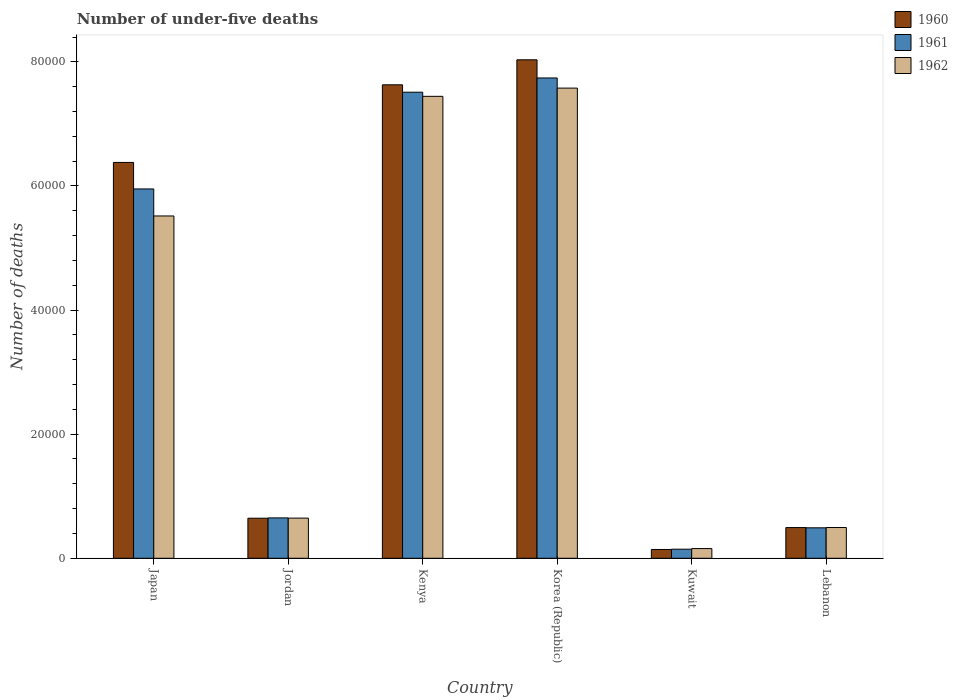How many groups of bars are there?
Provide a succinct answer. 6. Are the number of bars per tick equal to the number of legend labels?
Your answer should be compact. Yes. How many bars are there on the 3rd tick from the left?
Provide a succinct answer. 3. What is the number of under-five deaths in 1960 in Lebanon?
Ensure brevity in your answer.  4947. Across all countries, what is the maximum number of under-five deaths in 1962?
Offer a very short reply. 7.58e+04. Across all countries, what is the minimum number of under-five deaths in 1962?
Provide a short and direct response. 1563. In which country was the number of under-five deaths in 1962 minimum?
Give a very brief answer. Kuwait. What is the total number of under-five deaths in 1961 in the graph?
Keep it short and to the point. 2.25e+05. What is the difference between the number of under-five deaths in 1961 in Japan and that in Kuwait?
Provide a short and direct response. 5.81e+04. What is the difference between the number of under-five deaths in 1962 in Kenya and the number of under-five deaths in 1961 in Lebanon?
Your answer should be very brief. 6.95e+04. What is the average number of under-five deaths in 1961 per country?
Your response must be concise. 3.75e+04. What is the difference between the number of under-five deaths of/in 1962 and number of under-five deaths of/in 1960 in Kenya?
Keep it short and to the point. -1857. What is the ratio of the number of under-five deaths in 1961 in Japan to that in Lebanon?
Offer a very short reply. 12.13. Is the difference between the number of under-five deaths in 1962 in Japan and Lebanon greater than the difference between the number of under-five deaths in 1960 in Japan and Lebanon?
Provide a short and direct response. No. What is the difference between the highest and the second highest number of under-five deaths in 1962?
Offer a terse response. 1327. What is the difference between the highest and the lowest number of under-five deaths in 1962?
Ensure brevity in your answer.  7.42e+04. Is the sum of the number of under-five deaths in 1961 in Jordan and Kenya greater than the maximum number of under-five deaths in 1960 across all countries?
Provide a short and direct response. Yes. What does the 3rd bar from the right in Kenya represents?
Your answer should be very brief. 1960. Are all the bars in the graph horizontal?
Your response must be concise. No. What is the difference between two consecutive major ticks on the Y-axis?
Your answer should be compact. 2.00e+04. Does the graph contain grids?
Provide a succinct answer. No. How many legend labels are there?
Provide a succinct answer. 3. What is the title of the graph?
Provide a short and direct response. Number of under-five deaths. What is the label or title of the Y-axis?
Ensure brevity in your answer.  Number of deaths. What is the Number of deaths in 1960 in Japan?
Offer a terse response. 6.38e+04. What is the Number of deaths of 1961 in Japan?
Offer a terse response. 5.95e+04. What is the Number of deaths of 1962 in Japan?
Give a very brief answer. 5.52e+04. What is the Number of deaths in 1960 in Jordan?
Give a very brief answer. 6455. What is the Number of deaths in 1961 in Jordan?
Your answer should be compact. 6506. What is the Number of deaths in 1962 in Jordan?
Provide a short and direct response. 6471. What is the Number of deaths of 1960 in Kenya?
Your answer should be very brief. 7.63e+04. What is the Number of deaths of 1961 in Kenya?
Keep it short and to the point. 7.51e+04. What is the Number of deaths in 1962 in Kenya?
Ensure brevity in your answer.  7.44e+04. What is the Number of deaths in 1960 in Korea (Republic)?
Your answer should be compact. 8.03e+04. What is the Number of deaths of 1961 in Korea (Republic)?
Your answer should be compact. 7.74e+04. What is the Number of deaths of 1962 in Korea (Republic)?
Keep it short and to the point. 7.58e+04. What is the Number of deaths in 1960 in Kuwait?
Your response must be concise. 1416. What is the Number of deaths in 1961 in Kuwait?
Offer a terse response. 1463. What is the Number of deaths in 1962 in Kuwait?
Give a very brief answer. 1563. What is the Number of deaths of 1960 in Lebanon?
Make the answer very short. 4947. What is the Number of deaths in 1961 in Lebanon?
Your answer should be compact. 4907. What is the Number of deaths in 1962 in Lebanon?
Make the answer very short. 4956. Across all countries, what is the maximum Number of deaths of 1960?
Provide a succinct answer. 8.03e+04. Across all countries, what is the maximum Number of deaths in 1961?
Give a very brief answer. 7.74e+04. Across all countries, what is the maximum Number of deaths of 1962?
Offer a terse response. 7.58e+04. Across all countries, what is the minimum Number of deaths in 1960?
Offer a very short reply. 1416. Across all countries, what is the minimum Number of deaths of 1961?
Your answer should be very brief. 1463. Across all countries, what is the minimum Number of deaths of 1962?
Provide a succinct answer. 1563. What is the total Number of deaths in 1960 in the graph?
Your response must be concise. 2.33e+05. What is the total Number of deaths of 1961 in the graph?
Provide a succinct answer. 2.25e+05. What is the total Number of deaths in 1962 in the graph?
Your answer should be very brief. 2.18e+05. What is the difference between the Number of deaths of 1960 in Japan and that in Jordan?
Make the answer very short. 5.73e+04. What is the difference between the Number of deaths in 1961 in Japan and that in Jordan?
Offer a very short reply. 5.30e+04. What is the difference between the Number of deaths in 1962 in Japan and that in Jordan?
Provide a short and direct response. 4.87e+04. What is the difference between the Number of deaths in 1960 in Japan and that in Kenya?
Your answer should be compact. -1.25e+04. What is the difference between the Number of deaths of 1961 in Japan and that in Kenya?
Your answer should be compact. -1.56e+04. What is the difference between the Number of deaths in 1962 in Japan and that in Kenya?
Provide a short and direct response. -1.93e+04. What is the difference between the Number of deaths in 1960 in Japan and that in Korea (Republic)?
Keep it short and to the point. -1.65e+04. What is the difference between the Number of deaths of 1961 in Japan and that in Korea (Republic)?
Keep it short and to the point. -1.79e+04. What is the difference between the Number of deaths in 1962 in Japan and that in Korea (Republic)?
Ensure brevity in your answer.  -2.06e+04. What is the difference between the Number of deaths in 1960 in Japan and that in Kuwait?
Your answer should be compact. 6.24e+04. What is the difference between the Number of deaths of 1961 in Japan and that in Kuwait?
Offer a terse response. 5.81e+04. What is the difference between the Number of deaths in 1962 in Japan and that in Kuwait?
Ensure brevity in your answer.  5.36e+04. What is the difference between the Number of deaths of 1960 in Japan and that in Lebanon?
Make the answer very short. 5.88e+04. What is the difference between the Number of deaths of 1961 in Japan and that in Lebanon?
Give a very brief answer. 5.46e+04. What is the difference between the Number of deaths of 1962 in Japan and that in Lebanon?
Your response must be concise. 5.02e+04. What is the difference between the Number of deaths of 1960 in Jordan and that in Kenya?
Provide a succinct answer. -6.98e+04. What is the difference between the Number of deaths in 1961 in Jordan and that in Kenya?
Your answer should be compact. -6.86e+04. What is the difference between the Number of deaths in 1962 in Jordan and that in Kenya?
Your response must be concise. -6.80e+04. What is the difference between the Number of deaths in 1960 in Jordan and that in Korea (Republic)?
Your answer should be very brief. -7.39e+04. What is the difference between the Number of deaths in 1961 in Jordan and that in Korea (Republic)?
Keep it short and to the point. -7.09e+04. What is the difference between the Number of deaths in 1962 in Jordan and that in Korea (Republic)?
Keep it short and to the point. -6.93e+04. What is the difference between the Number of deaths of 1960 in Jordan and that in Kuwait?
Make the answer very short. 5039. What is the difference between the Number of deaths in 1961 in Jordan and that in Kuwait?
Your answer should be very brief. 5043. What is the difference between the Number of deaths in 1962 in Jordan and that in Kuwait?
Make the answer very short. 4908. What is the difference between the Number of deaths of 1960 in Jordan and that in Lebanon?
Offer a very short reply. 1508. What is the difference between the Number of deaths in 1961 in Jordan and that in Lebanon?
Keep it short and to the point. 1599. What is the difference between the Number of deaths of 1962 in Jordan and that in Lebanon?
Your response must be concise. 1515. What is the difference between the Number of deaths of 1960 in Kenya and that in Korea (Republic)?
Offer a very short reply. -4031. What is the difference between the Number of deaths of 1961 in Kenya and that in Korea (Republic)?
Offer a very short reply. -2297. What is the difference between the Number of deaths in 1962 in Kenya and that in Korea (Republic)?
Your response must be concise. -1327. What is the difference between the Number of deaths in 1960 in Kenya and that in Kuwait?
Offer a very short reply. 7.49e+04. What is the difference between the Number of deaths in 1961 in Kenya and that in Kuwait?
Ensure brevity in your answer.  7.36e+04. What is the difference between the Number of deaths of 1962 in Kenya and that in Kuwait?
Provide a succinct answer. 7.29e+04. What is the difference between the Number of deaths in 1960 in Kenya and that in Lebanon?
Make the answer very short. 7.14e+04. What is the difference between the Number of deaths in 1961 in Kenya and that in Lebanon?
Make the answer very short. 7.02e+04. What is the difference between the Number of deaths of 1962 in Kenya and that in Lebanon?
Offer a very short reply. 6.95e+04. What is the difference between the Number of deaths of 1960 in Korea (Republic) and that in Kuwait?
Make the answer very short. 7.89e+04. What is the difference between the Number of deaths of 1961 in Korea (Republic) and that in Kuwait?
Your answer should be very brief. 7.59e+04. What is the difference between the Number of deaths in 1962 in Korea (Republic) and that in Kuwait?
Provide a succinct answer. 7.42e+04. What is the difference between the Number of deaths in 1960 in Korea (Republic) and that in Lebanon?
Offer a terse response. 7.54e+04. What is the difference between the Number of deaths in 1961 in Korea (Republic) and that in Lebanon?
Keep it short and to the point. 7.25e+04. What is the difference between the Number of deaths of 1962 in Korea (Republic) and that in Lebanon?
Keep it short and to the point. 7.08e+04. What is the difference between the Number of deaths of 1960 in Kuwait and that in Lebanon?
Provide a succinct answer. -3531. What is the difference between the Number of deaths of 1961 in Kuwait and that in Lebanon?
Your answer should be compact. -3444. What is the difference between the Number of deaths of 1962 in Kuwait and that in Lebanon?
Ensure brevity in your answer.  -3393. What is the difference between the Number of deaths of 1960 in Japan and the Number of deaths of 1961 in Jordan?
Offer a terse response. 5.73e+04. What is the difference between the Number of deaths in 1960 in Japan and the Number of deaths in 1962 in Jordan?
Your answer should be very brief. 5.73e+04. What is the difference between the Number of deaths of 1961 in Japan and the Number of deaths of 1962 in Jordan?
Your answer should be compact. 5.30e+04. What is the difference between the Number of deaths in 1960 in Japan and the Number of deaths in 1961 in Kenya?
Keep it short and to the point. -1.13e+04. What is the difference between the Number of deaths of 1960 in Japan and the Number of deaths of 1962 in Kenya?
Provide a short and direct response. -1.07e+04. What is the difference between the Number of deaths in 1961 in Japan and the Number of deaths in 1962 in Kenya?
Make the answer very short. -1.49e+04. What is the difference between the Number of deaths in 1960 in Japan and the Number of deaths in 1961 in Korea (Republic)?
Provide a short and direct response. -1.36e+04. What is the difference between the Number of deaths of 1960 in Japan and the Number of deaths of 1962 in Korea (Republic)?
Offer a terse response. -1.20e+04. What is the difference between the Number of deaths in 1961 in Japan and the Number of deaths in 1962 in Korea (Republic)?
Offer a very short reply. -1.63e+04. What is the difference between the Number of deaths of 1960 in Japan and the Number of deaths of 1961 in Kuwait?
Offer a very short reply. 6.23e+04. What is the difference between the Number of deaths of 1960 in Japan and the Number of deaths of 1962 in Kuwait?
Provide a short and direct response. 6.22e+04. What is the difference between the Number of deaths of 1961 in Japan and the Number of deaths of 1962 in Kuwait?
Give a very brief answer. 5.80e+04. What is the difference between the Number of deaths of 1960 in Japan and the Number of deaths of 1961 in Lebanon?
Offer a very short reply. 5.89e+04. What is the difference between the Number of deaths in 1960 in Japan and the Number of deaths in 1962 in Lebanon?
Provide a short and direct response. 5.88e+04. What is the difference between the Number of deaths of 1961 in Japan and the Number of deaths of 1962 in Lebanon?
Give a very brief answer. 5.46e+04. What is the difference between the Number of deaths in 1960 in Jordan and the Number of deaths in 1961 in Kenya?
Your response must be concise. -6.86e+04. What is the difference between the Number of deaths in 1960 in Jordan and the Number of deaths in 1962 in Kenya?
Provide a short and direct response. -6.80e+04. What is the difference between the Number of deaths in 1961 in Jordan and the Number of deaths in 1962 in Kenya?
Give a very brief answer. -6.79e+04. What is the difference between the Number of deaths in 1960 in Jordan and the Number of deaths in 1961 in Korea (Republic)?
Offer a very short reply. -7.09e+04. What is the difference between the Number of deaths of 1960 in Jordan and the Number of deaths of 1962 in Korea (Republic)?
Make the answer very short. -6.93e+04. What is the difference between the Number of deaths in 1961 in Jordan and the Number of deaths in 1962 in Korea (Republic)?
Ensure brevity in your answer.  -6.93e+04. What is the difference between the Number of deaths of 1960 in Jordan and the Number of deaths of 1961 in Kuwait?
Your response must be concise. 4992. What is the difference between the Number of deaths of 1960 in Jordan and the Number of deaths of 1962 in Kuwait?
Offer a terse response. 4892. What is the difference between the Number of deaths of 1961 in Jordan and the Number of deaths of 1962 in Kuwait?
Offer a terse response. 4943. What is the difference between the Number of deaths in 1960 in Jordan and the Number of deaths in 1961 in Lebanon?
Provide a short and direct response. 1548. What is the difference between the Number of deaths in 1960 in Jordan and the Number of deaths in 1962 in Lebanon?
Offer a terse response. 1499. What is the difference between the Number of deaths in 1961 in Jordan and the Number of deaths in 1962 in Lebanon?
Provide a short and direct response. 1550. What is the difference between the Number of deaths of 1960 in Kenya and the Number of deaths of 1961 in Korea (Republic)?
Keep it short and to the point. -1104. What is the difference between the Number of deaths in 1960 in Kenya and the Number of deaths in 1962 in Korea (Republic)?
Offer a terse response. 530. What is the difference between the Number of deaths in 1961 in Kenya and the Number of deaths in 1962 in Korea (Republic)?
Provide a succinct answer. -663. What is the difference between the Number of deaths of 1960 in Kenya and the Number of deaths of 1961 in Kuwait?
Provide a succinct answer. 7.48e+04. What is the difference between the Number of deaths in 1960 in Kenya and the Number of deaths in 1962 in Kuwait?
Keep it short and to the point. 7.47e+04. What is the difference between the Number of deaths of 1961 in Kenya and the Number of deaths of 1962 in Kuwait?
Provide a short and direct response. 7.35e+04. What is the difference between the Number of deaths of 1960 in Kenya and the Number of deaths of 1961 in Lebanon?
Ensure brevity in your answer.  7.14e+04. What is the difference between the Number of deaths in 1960 in Kenya and the Number of deaths in 1962 in Lebanon?
Make the answer very short. 7.13e+04. What is the difference between the Number of deaths of 1961 in Kenya and the Number of deaths of 1962 in Lebanon?
Make the answer very short. 7.01e+04. What is the difference between the Number of deaths in 1960 in Korea (Republic) and the Number of deaths in 1961 in Kuwait?
Provide a succinct answer. 7.89e+04. What is the difference between the Number of deaths in 1960 in Korea (Republic) and the Number of deaths in 1962 in Kuwait?
Your answer should be compact. 7.88e+04. What is the difference between the Number of deaths of 1961 in Korea (Republic) and the Number of deaths of 1962 in Kuwait?
Make the answer very short. 7.58e+04. What is the difference between the Number of deaths of 1960 in Korea (Republic) and the Number of deaths of 1961 in Lebanon?
Keep it short and to the point. 7.54e+04. What is the difference between the Number of deaths in 1960 in Korea (Republic) and the Number of deaths in 1962 in Lebanon?
Keep it short and to the point. 7.54e+04. What is the difference between the Number of deaths of 1961 in Korea (Republic) and the Number of deaths of 1962 in Lebanon?
Your response must be concise. 7.24e+04. What is the difference between the Number of deaths of 1960 in Kuwait and the Number of deaths of 1961 in Lebanon?
Offer a terse response. -3491. What is the difference between the Number of deaths in 1960 in Kuwait and the Number of deaths in 1962 in Lebanon?
Give a very brief answer. -3540. What is the difference between the Number of deaths in 1961 in Kuwait and the Number of deaths in 1962 in Lebanon?
Make the answer very short. -3493. What is the average Number of deaths in 1960 per country?
Offer a terse response. 3.89e+04. What is the average Number of deaths in 1961 per country?
Provide a succinct answer. 3.75e+04. What is the average Number of deaths of 1962 per country?
Offer a terse response. 3.64e+04. What is the difference between the Number of deaths in 1960 and Number of deaths in 1961 in Japan?
Make the answer very short. 4272. What is the difference between the Number of deaths in 1960 and Number of deaths in 1962 in Japan?
Ensure brevity in your answer.  8625. What is the difference between the Number of deaths in 1961 and Number of deaths in 1962 in Japan?
Offer a very short reply. 4353. What is the difference between the Number of deaths in 1960 and Number of deaths in 1961 in Jordan?
Ensure brevity in your answer.  -51. What is the difference between the Number of deaths in 1960 and Number of deaths in 1961 in Kenya?
Keep it short and to the point. 1193. What is the difference between the Number of deaths in 1960 and Number of deaths in 1962 in Kenya?
Offer a very short reply. 1857. What is the difference between the Number of deaths of 1961 and Number of deaths of 1962 in Kenya?
Your answer should be very brief. 664. What is the difference between the Number of deaths of 1960 and Number of deaths of 1961 in Korea (Republic)?
Offer a terse response. 2927. What is the difference between the Number of deaths of 1960 and Number of deaths of 1962 in Korea (Republic)?
Your response must be concise. 4561. What is the difference between the Number of deaths of 1961 and Number of deaths of 1962 in Korea (Republic)?
Offer a very short reply. 1634. What is the difference between the Number of deaths in 1960 and Number of deaths in 1961 in Kuwait?
Offer a very short reply. -47. What is the difference between the Number of deaths in 1960 and Number of deaths in 1962 in Kuwait?
Make the answer very short. -147. What is the difference between the Number of deaths in 1961 and Number of deaths in 1962 in Kuwait?
Your answer should be very brief. -100. What is the difference between the Number of deaths of 1960 and Number of deaths of 1961 in Lebanon?
Give a very brief answer. 40. What is the difference between the Number of deaths in 1961 and Number of deaths in 1962 in Lebanon?
Provide a short and direct response. -49. What is the ratio of the Number of deaths of 1960 in Japan to that in Jordan?
Make the answer very short. 9.88. What is the ratio of the Number of deaths of 1961 in Japan to that in Jordan?
Ensure brevity in your answer.  9.15. What is the ratio of the Number of deaths of 1962 in Japan to that in Jordan?
Ensure brevity in your answer.  8.52. What is the ratio of the Number of deaths in 1960 in Japan to that in Kenya?
Your answer should be compact. 0.84. What is the ratio of the Number of deaths in 1961 in Japan to that in Kenya?
Your response must be concise. 0.79. What is the ratio of the Number of deaths of 1962 in Japan to that in Kenya?
Keep it short and to the point. 0.74. What is the ratio of the Number of deaths of 1960 in Japan to that in Korea (Republic)?
Keep it short and to the point. 0.79. What is the ratio of the Number of deaths in 1961 in Japan to that in Korea (Republic)?
Provide a short and direct response. 0.77. What is the ratio of the Number of deaths in 1962 in Japan to that in Korea (Republic)?
Ensure brevity in your answer.  0.73. What is the ratio of the Number of deaths in 1960 in Japan to that in Kuwait?
Offer a terse response. 45.05. What is the ratio of the Number of deaths in 1961 in Japan to that in Kuwait?
Provide a short and direct response. 40.68. What is the ratio of the Number of deaths in 1962 in Japan to that in Kuwait?
Offer a very short reply. 35.29. What is the ratio of the Number of deaths of 1960 in Japan to that in Lebanon?
Provide a succinct answer. 12.89. What is the ratio of the Number of deaths in 1961 in Japan to that in Lebanon?
Provide a succinct answer. 12.13. What is the ratio of the Number of deaths in 1962 in Japan to that in Lebanon?
Ensure brevity in your answer.  11.13. What is the ratio of the Number of deaths of 1960 in Jordan to that in Kenya?
Offer a terse response. 0.08. What is the ratio of the Number of deaths of 1961 in Jordan to that in Kenya?
Ensure brevity in your answer.  0.09. What is the ratio of the Number of deaths in 1962 in Jordan to that in Kenya?
Your answer should be very brief. 0.09. What is the ratio of the Number of deaths of 1960 in Jordan to that in Korea (Republic)?
Provide a succinct answer. 0.08. What is the ratio of the Number of deaths in 1961 in Jordan to that in Korea (Republic)?
Keep it short and to the point. 0.08. What is the ratio of the Number of deaths of 1962 in Jordan to that in Korea (Republic)?
Provide a short and direct response. 0.09. What is the ratio of the Number of deaths in 1960 in Jordan to that in Kuwait?
Ensure brevity in your answer.  4.56. What is the ratio of the Number of deaths of 1961 in Jordan to that in Kuwait?
Offer a terse response. 4.45. What is the ratio of the Number of deaths in 1962 in Jordan to that in Kuwait?
Your answer should be compact. 4.14. What is the ratio of the Number of deaths in 1960 in Jordan to that in Lebanon?
Offer a very short reply. 1.3. What is the ratio of the Number of deaths in 1961 in Jordan to that in Lebanon?
Provide a short and direct response. 1.33. What is the ratio of the Number of deaths in 1962 in Jordan to that in Lebanon?
Keep it short and to the point. 1.31. What is the ratio of the Number of deaths in 1960 in Kenya to that in Korea (Republic)?
Your answer should be compact. 0.95. What is the ratio of the Number of deaths in 1961 in Kenya to that in Korea (Republic)?
Keep it short and to the point. 0.97. What is the ratio of the Number of deaths in 1962 in Kenya to that in Korea (Republic)?
Provide a succinct answer. 0.98. What is the ratio of the Number of deaths of 1960 in Kenya to that in Kuwait?
Provide a short and direct response. 53.88. What is the ratio of the Number of deaths of 1961 in Kenya to that in Kuwait?
Give a very brief answer. 51.34. What is the ratio of the Number of deaths of 1962 in Kenya to that in Kuwait?
Make the answer very short. 47.63. What is the ratio of the Number of deaths in 1960 in Kenya to that in Lebanon?
Ensure brevity in your answer.  15.42. What is the ratio of the Number of deaths of 1961 in Kenya to that in Lebanon?
Make the answer very short. 15.31. What is the ratio of the Number of deaths in 1962 in Kenya to that in Lebanon?
Make the answer very short. 15.02. What is the ratio of the Number of deaths in 1960 in Korea (Republic) to that in Kuwait?
Ensure brevity in your answer.  56.73. What is the ratio of the Number of deaths in 1961 in Korea (Republic) to that in Kuwait?
Your answer should be compact. 52.91. What is the ratio of the Number of deaths of 1962 in Korea (Republic) to that in Kuwait?
Your answer should be very brief. 48.48. What is the ratio of the Number of deaths of 1960 in Korea (Republic) to that in Lebanon?
Offer a very short reply. 16.24. What is the ratio of the Number of deaths of 1961 in Korea (Republic) to that in Lebanon?
Give a very brief answer. 15.77. What is the ratio of the Number of deaths in 1962 in Korea (Republic) to that in Lebanon?
Ensure brevity in your answer.  15.29. What is the ratio of the Number of deaths of 1960 in Kuwait to that in Lebanon?
Provide a short and direct response. 0.29. What is the ratio of the Number of deaths of 1961 in Kuwait to that in Lebanon?
Give a very brief answer. 0.3. What is the ratio of the Number of deaths of 1962 in Kuwait to that in Lebanon?
Offer a terse response. 0.32. What is the difference between the highest and the second highest Number of deaths in 1960?
Offer a very short reply. 4031. What is the difference between the highest and the second highest Number of deaths in 1961?
Provide a succinct answer. 2297. What is the difference between the highest and the second highest Number of deaths in 1962?
Your answer should be very brief. 1327. What is the difference between the highest and the lowest Number of deaths of 1960?
Offer a very short reply. 7.89e+04. What is the difference between the highest and the lowest Number of deaths in 1961?
Your answer should be very brief. 7.59e+04. What is the difference between the highest and the lowest Number of deaths of 1962?
Offer a very short reply. 7.42e+04. 